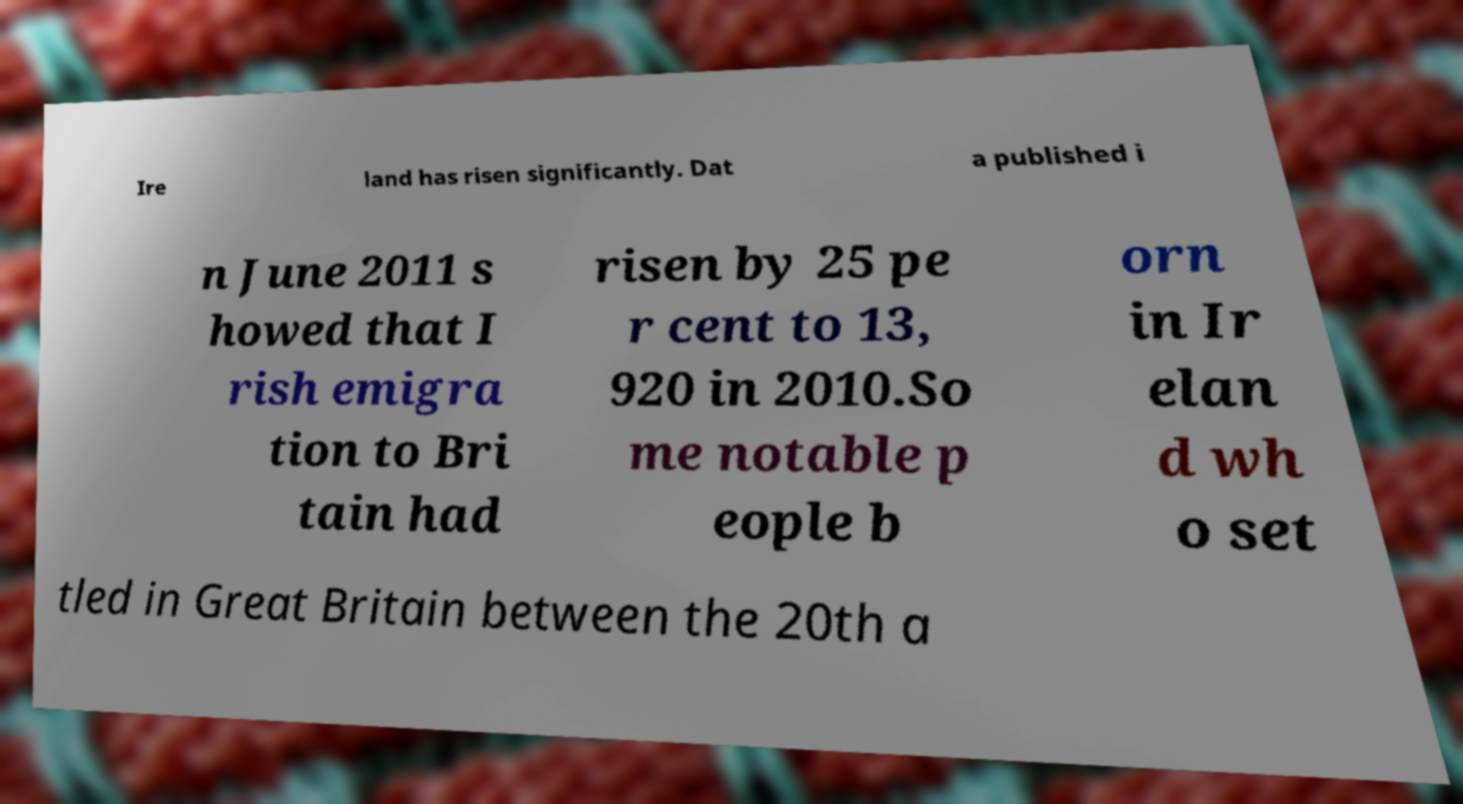What messages or text are displayed in this image? I need them in a readable, typed format. Ire land has risen significantly. Dat a published i n June 2011 s howed that I rish emigra tion to Bri tain had risen by 25 pe r cent to 13, 920 in 2010.So me notable p eople b orn in Ir elan d wh o set tled in Great Britain between the 20th a 